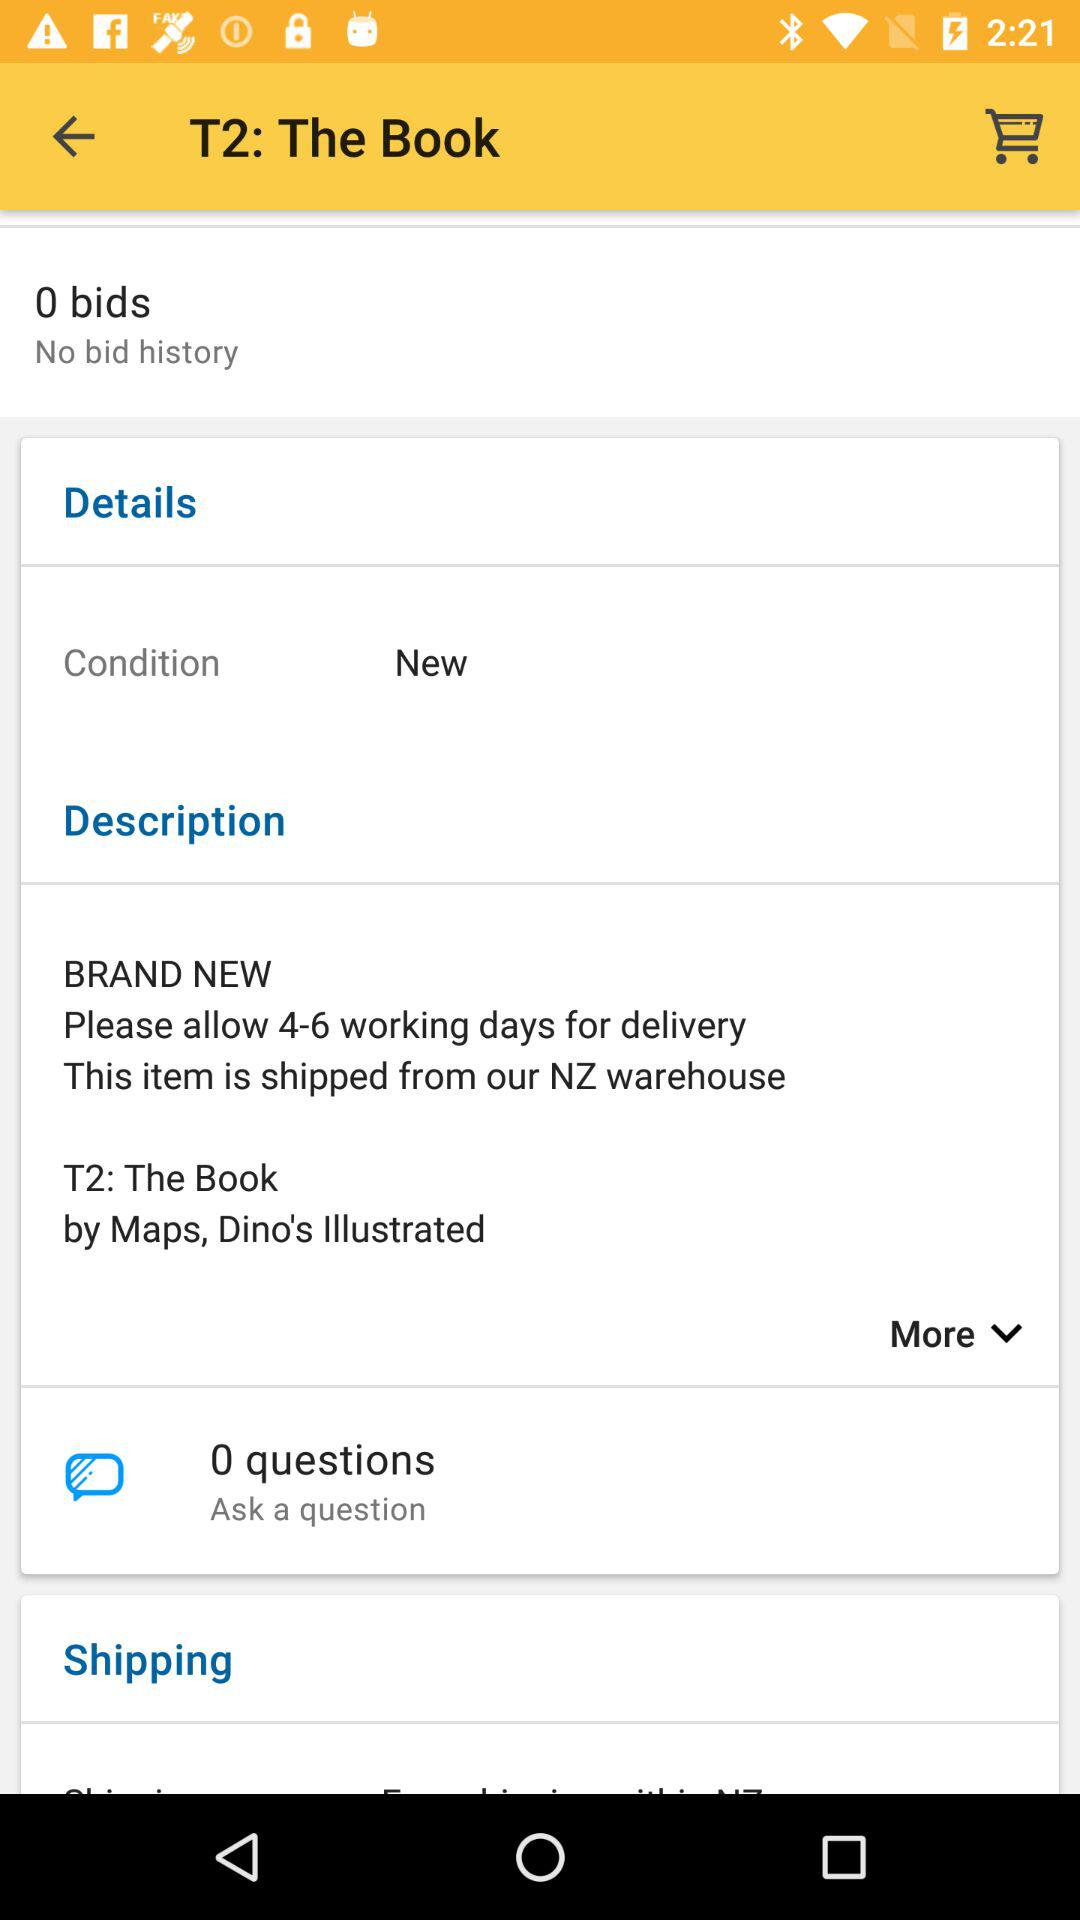What is the title of T2? The title of T2 is "The Book". 